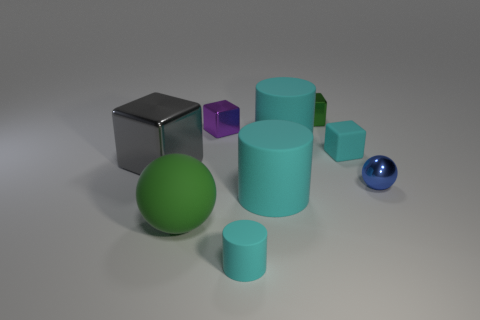Do the green thing behind the big rubber ball and the cyan cube have the same material?
Provide a short and direct response. No. What material is the tiny blue thing that is the same shape as the green rubber thing?
Provide a short and direct response. Metal. What is the material of the block that is the same color as the big sphere?
Your answer should be compact. Metal. Is the number of big yellow rubber objects less than the number of large gray objects?
Provide a short and direct response. Yes. Does the ball on the right side of the tiny green shiny cube have the same color as the matte cube?
Give a very brief answer. No. There is a big object that is the same material as the tiny purple block; what is its color?
Offer a terse response. Gray. Is the size of the purple object the same as the green metal block?
Your answer should be very brief. Yes. What is the cyan cube made of?
Provide a short and direct response. Rubber. There is a green object that is the same size as the gray shiny block; what is its material?
Your response must be concise. Rubber. Is there a gray metallic thing that has the same size as the purple metallic object?
Ensure brevity in your answer.  No. 